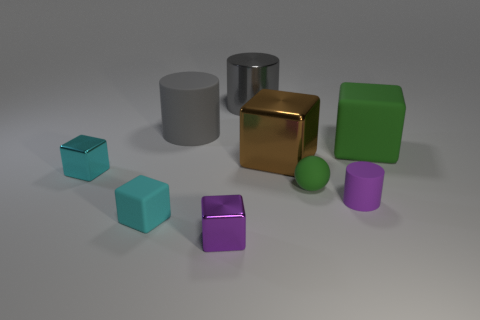There is a cube that is the same color as the small cylinder; what material is it? metal 